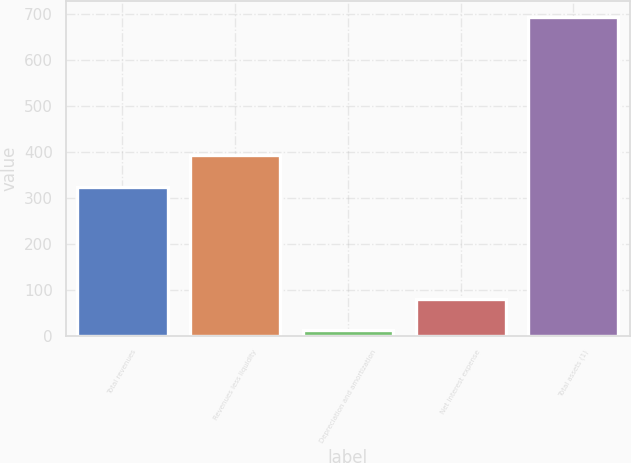Convert chart. <chart><loc_0><loc_0><loc_500><loc_500><bar_chart><fcel>Total revenues<fcel>Revenues less liquidity<fcel>Depreciation and amortization<fcel>Net interest expense<fcel>Total assets (1)<nl><fcel>324<fcel>392.1<fcel>11<fcel>79.1<fcel>692<nl></chart> 